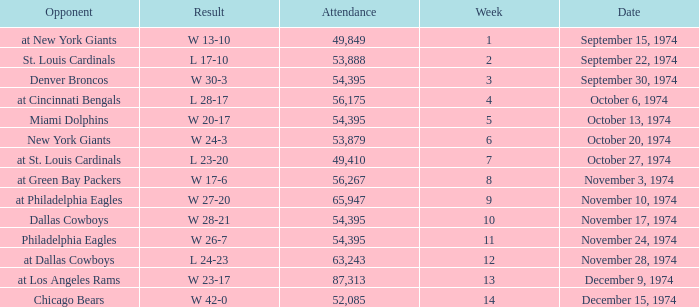What was the result of the game where 63,243 people attended after week 9? W 23-17. 